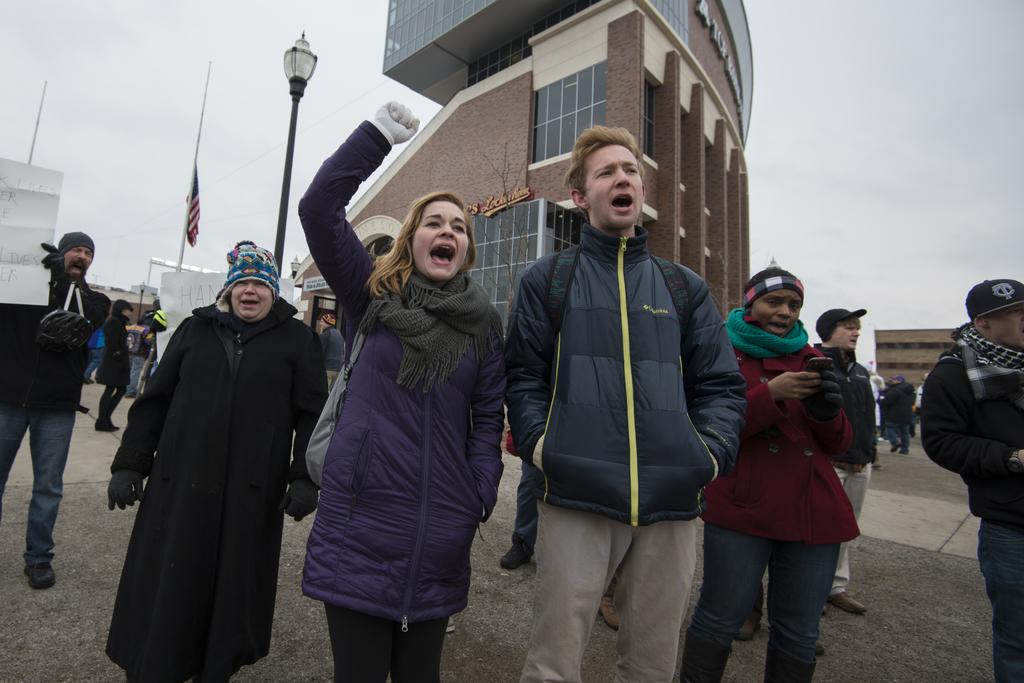Who is present in the image? There are people in the image. What are the people holding in the image? The people are holding boards. Where are the people standing in the image? The people are standing on the road. What can be seen in the background of the image? There are buildings visible in the background of the image. How many geese are sleeping on the beds in the image? There are no geese or beds present in the image. What is the grandfather doing in the image? There is no grandfather present in the image. 